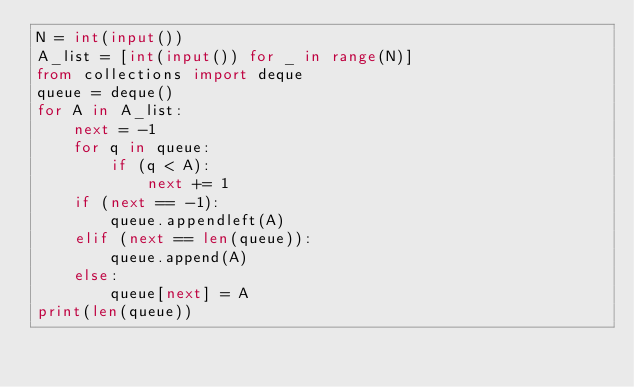<code> <loc_0><loc_0><loc_500><loc_500><_Python_>N = int(input())
A_list = [int(input()) for _ in range(N)]
from collections import deque
queue = deque()
for A in A_list:
    next = -1
    for q in queue:
        if (q < A):
            next += 1
    if (next == -1):
        queue.appendleft(A)
    elif (next == len(queue)):
        queue.append(A)
    else:
        queue[next] = A
print(len(queue))
</code> 